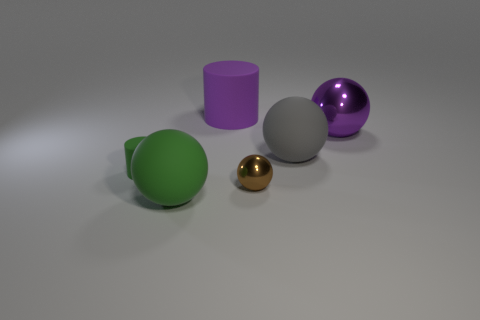What color is the other small object that is made of the same material as the gray object?
Your response must be concise. Green. What number of metal balls are behind the tiny object right of the green ball?
Give a very brief answer. 1. What is the object that is behind the large gray sphere and on the left side of the purple shiny sphere made of?
Provide a short and direct response. Rubber. Do the matte object that is left of the large green rubber ball and the brown metal object have the same shape?
Your response must be concise. No. Are there fewer large gray spheres than rubber things?
Your response must be concise. Yes. How many large metallic things are the same color as the big rubber cylinder?
Ensure brevity in your answer.  1. There is a big thing that is the same color as the large matte cylinder; what is its material?
Your answer should be compact. Metal. Is the color of the tiny ball the same as the matte ball that is in front of the tiny brown shiny thing?
Your response must be concise. No. Is the number of large shiny cylinders greater than the number of green matte cylinders?
Give a very brief answer. No. There is a brown metal object that is the same shape as the gray object; what is its size?
Give a very brief answer. Small. 